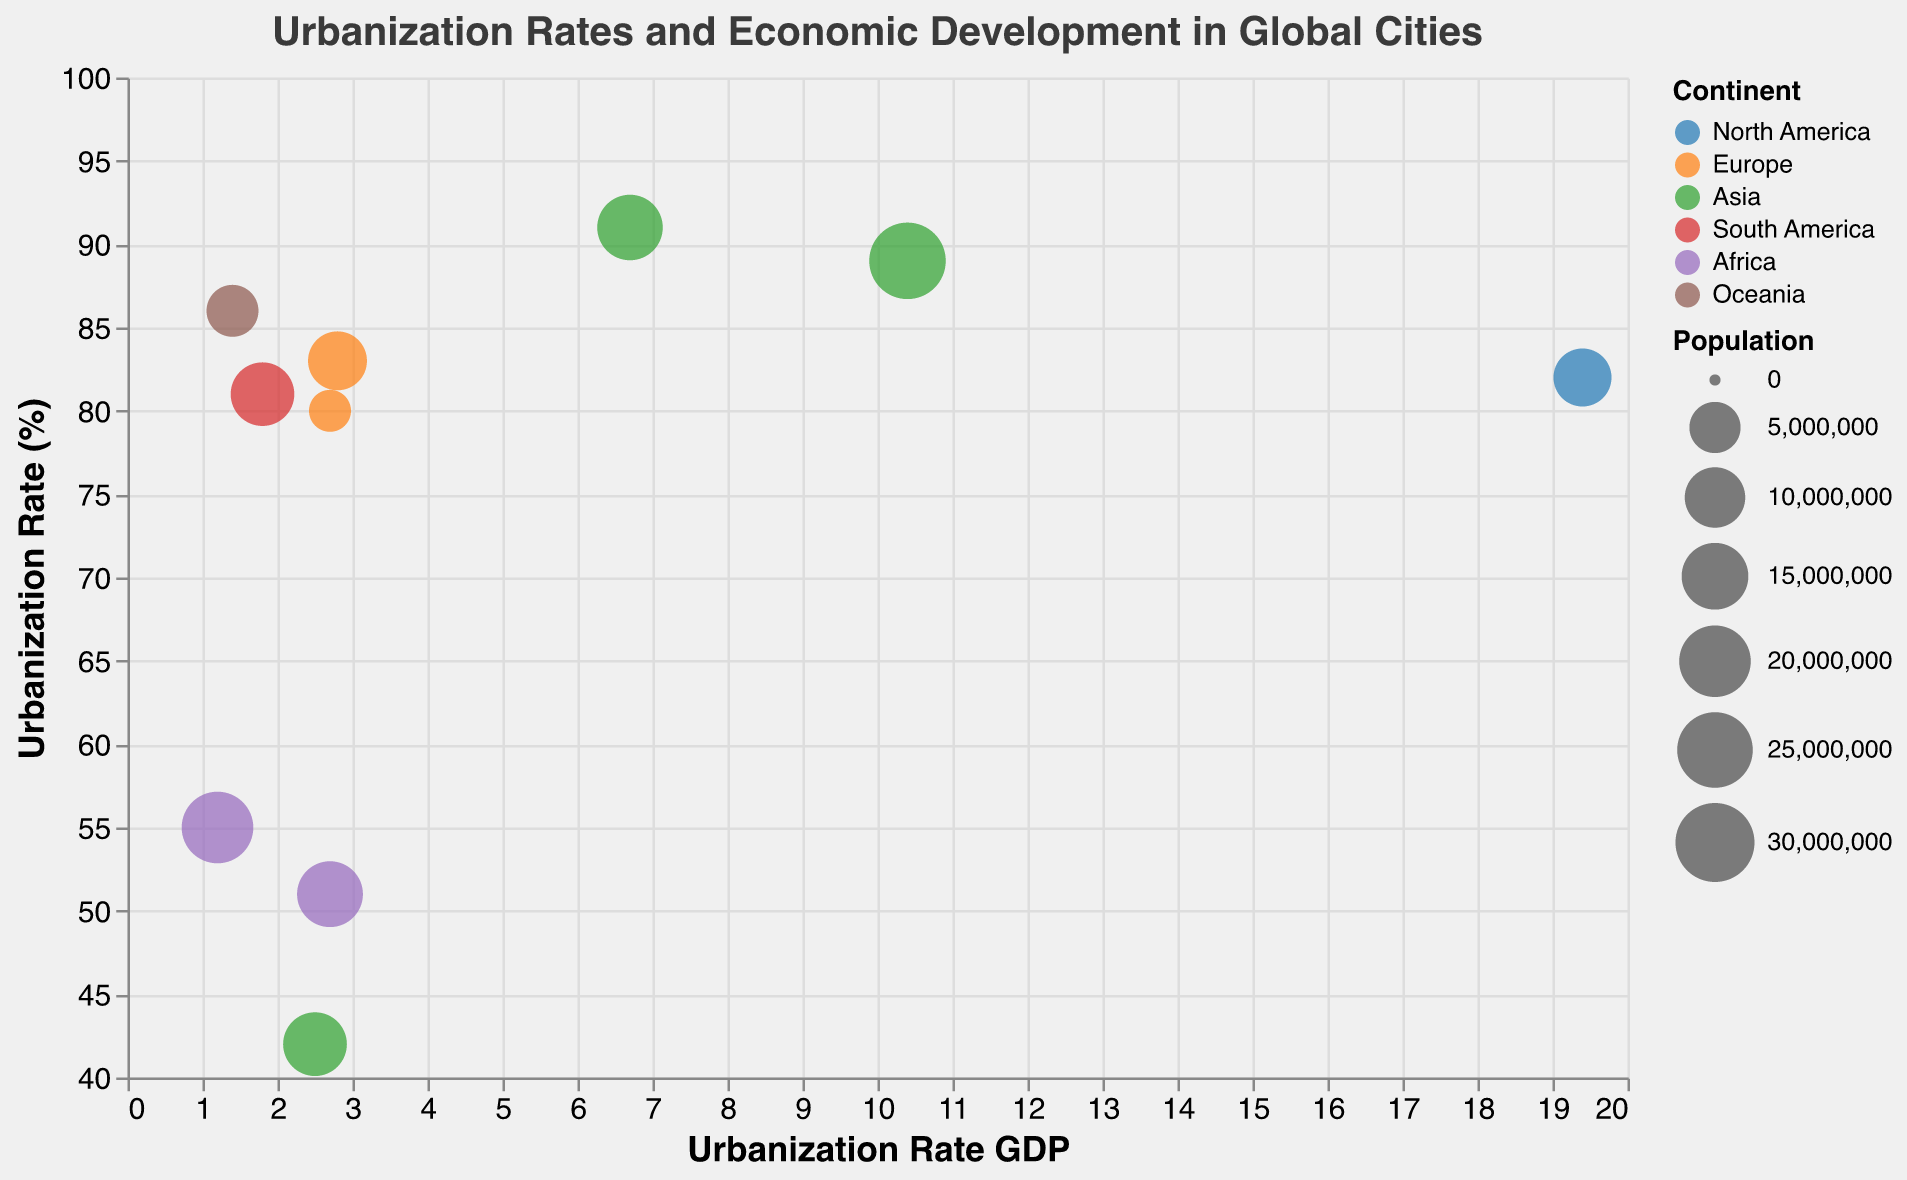Which city has the highest urbanization rate? The 'Urbanization Rate (%)' axis shows the degree of urbanization. By examining the plot, Tokyo has the highest urbanization rate at 91%.
Answer: Tokyo What is the urbanization rate GDP of New York? The 'Urbanization Rate GDP' axis and the placement of New York on the plot can be used to determine this value. New York's urbanization rate GDP is 19.4.
Answer: 19.4 Which city in Africa has the higher urbanization rate? Looking at data points colored to represent Africa, Lagos and Cairo are the cities. Comparing their positions on the 'Urbanization Rate (%)' axis, Lagos has 51% and Cairo has 55%. Cairo has the higher urbanization rate.
Answer: Cairo Among the cities in Asia, which one has the lowest population? By comparing the bubble sizes for the cities in Asia (Tokyo, Shanghai, and Mumbai), Mumbai, which has the smallest bubble, has the lowest population.
Answer: Mumbai How many cities have an urbanization rate GDP above 10? Examining the plot for data points with an 'Urbanization Rate GDP' above 10, only Shanghai qualifies.
Answer: 1 Which continent is represented by the most number of cities in the plot? By counting the bubbles for each color that represents a continent; Asia, with Tokyo, Shanghai, and Mumbai, has the most representation.
Answer: Asia What’s the average urbanization rate (%) for the cities in Europe? First find the urbanization rates of London (83%) and Paris (80%). The average is calculated as (83 + 80) / 2 = 81.5.
Answer: 81.5 Compare the population sizes of São Paulo and Cairo. Which city is larger? The bubble size indicates the population; Cairo has a larger bubble compared to São Paulo, indicating it has a larger population.
Answer: Cairo What is the urbanization rate GDP and urbanization rate (%) of the smallest city by population? The plot shows that Paris has the smallest bubble, representing lowest population. Paris has an urbanization rate GDP of 2.7 and an urbanization rate of 80%.
Answer: 2.7, 80% Which city in North America is included in the plot? By looking at the color representing North America, there is one data point belonging to this continent, and that city is New York.
Answer: New York 